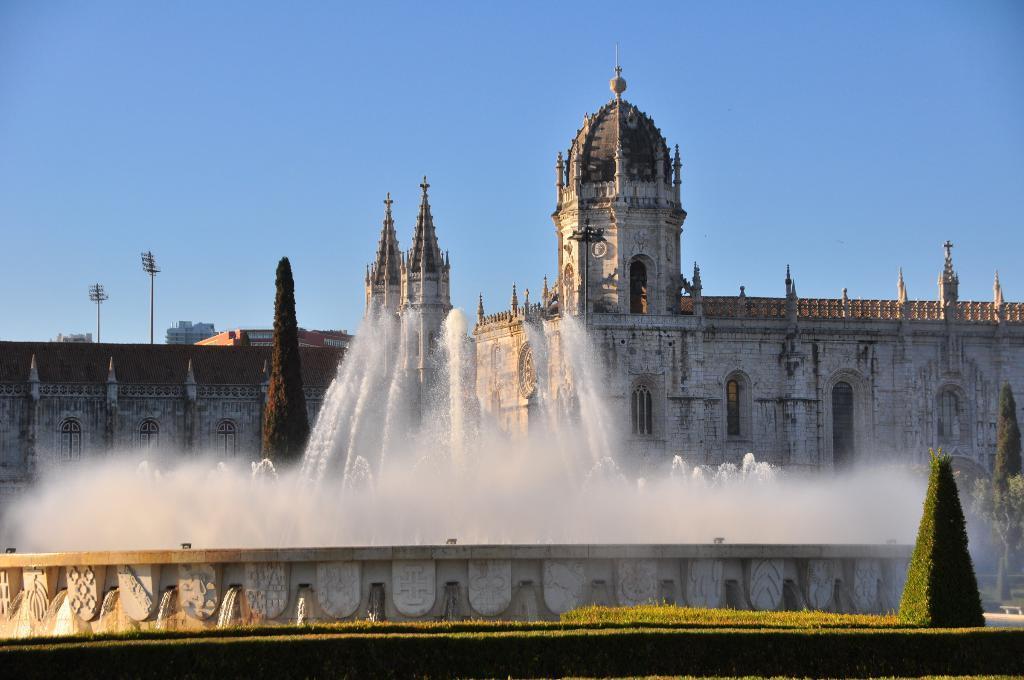Please provide a concise description of this image. In this image we can see a big building. There is a fountain in front of the building. There are many plants in the image. 